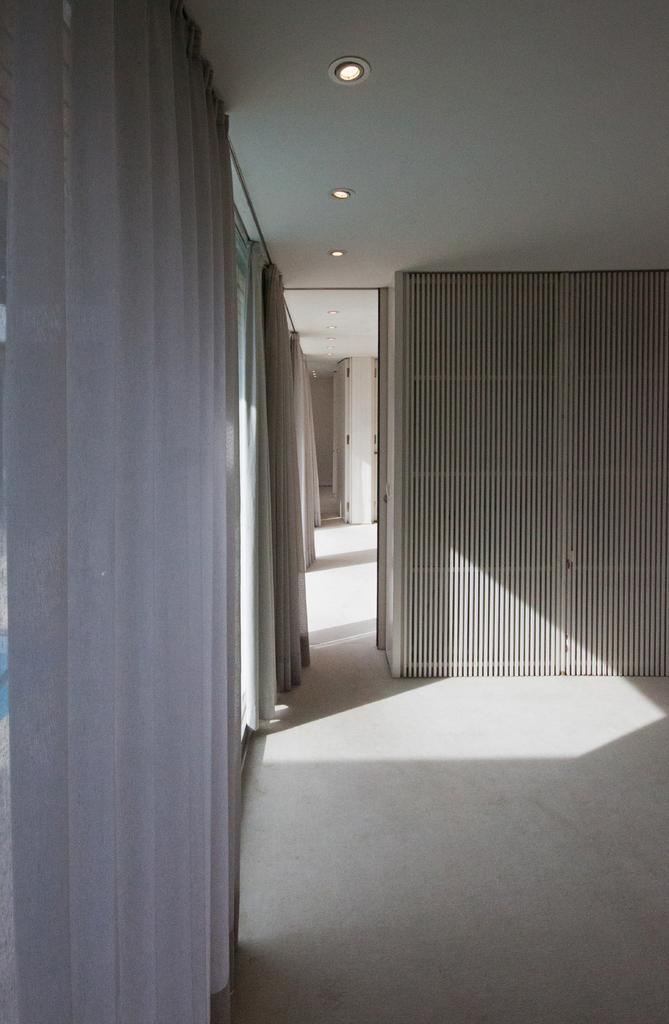What type of surface is present in the image? The image contains a floor. What is located on the sides or edges of the image? There is a wall in the image. What type of window treatment is present in the image? The image contains curtains. What type of illumination is present in the image? The image contains lights. What can be seen in the background of the image? There are objects visible in the background of the image. What type of kitty can be seen playing in the sky in the image? There is no kitty or sky present in the image; it does not depict an outdoor scene. 